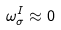<formula> <loc_0><loc_0><loc_500><loc_500>\omega ^ { I } _ { \sigma } \approx 0</formula> 